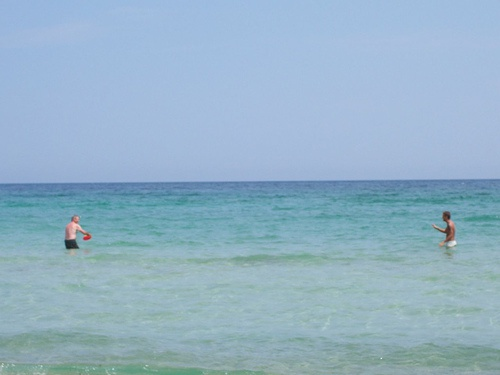Describe the objects in this image and their specific colors. I can see people in lightblue, darkgray, gray, brown, and maroon tones, people in lightblue, lightpink, black, gray, and darkgray tones, and frisbee in lightblue, brown, and darkgray tones in this image. 